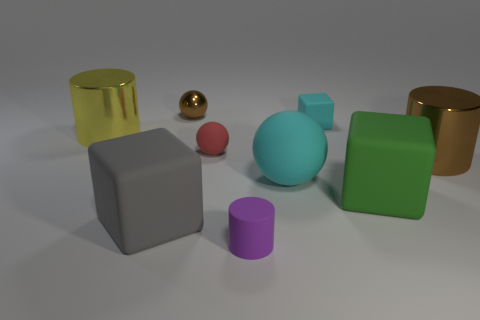Are there the same number of green objects that are behind the tiny red rubber ball and cyan rubber cubes in front of the large cyan ball?
Provide a succinct answer. Yes. Does the tiny cyan thing have the same shape as the yellow metallic thing?
Your response must be concise. No. There is a large object that is both to the left of the green cube and behind the large cyan matte ball; what material is it made of?
Ensure brevity in your answer.  Metal. How many cyan objects have the same shape as the gray object?
Your answer should be very brief. 1. There is a cyan ball that is in front of the brown object that is in front of the yellow shiny thing that is behind the large ball; what size is it?
Give a very brief answer. Large. Are there more big yellow shiny objects behind the large green rubber thing than large red metal spheres?
Give a very brief answer. Yes. Is there a tiny yellow cylinder?
Your answer should be compact. No. How many green rubber things have the same size as the gray rubber block?
Provide a short and direct response. 1. Is the number of brown balls that are left of the metallic ball greater than the number of shiny things that are on the left side of the big cyan ball?
Your answer should be compact. No. What is the material of the brown object that is the same size as the green block?
Ensure brevity in your answer.  Metal. 